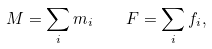<formula> <loc_0><loc_0><loc_500><loc_500>M = \sum _ { i } m _ { i } \quad F = \sum _ { i } f _ { i } ,</formula> 